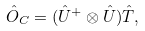Convert formula to latex. <formula><loc_0><loc_0><loc_500><loc_500>\hat { O } _ { C } = ( \hat { U } ^ { + } \otimes \hat { U } ) \hat { T } ,</formula> 